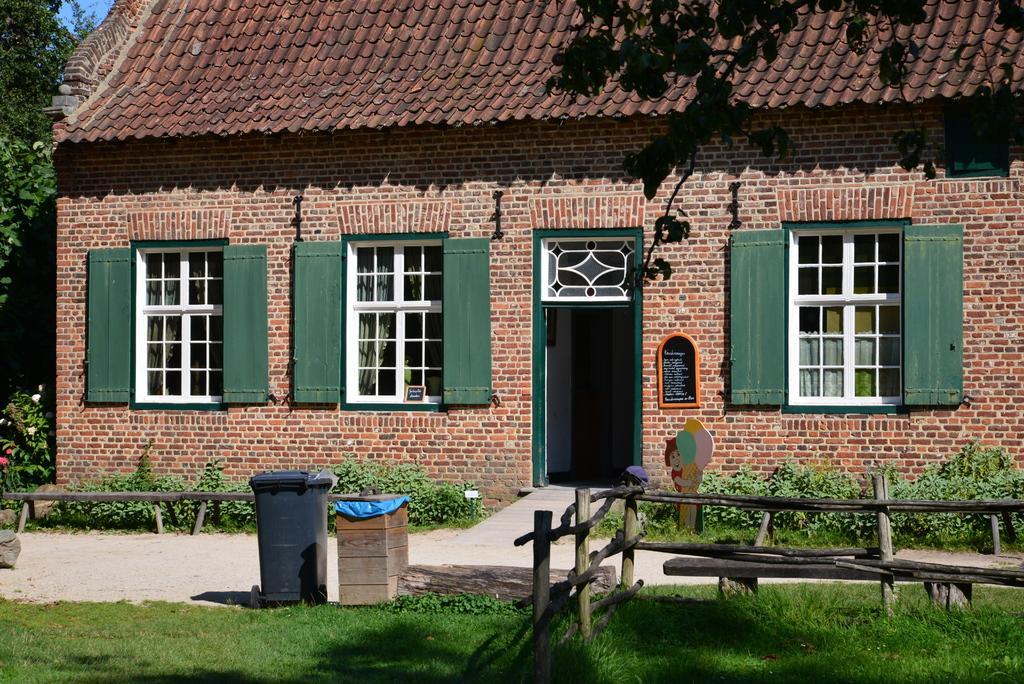How would you summarize this image in a sentence or two? In this picture we can see house with windows opened, door, board and in front of the house we have path, trees, grass, wooden sticks, bin. 